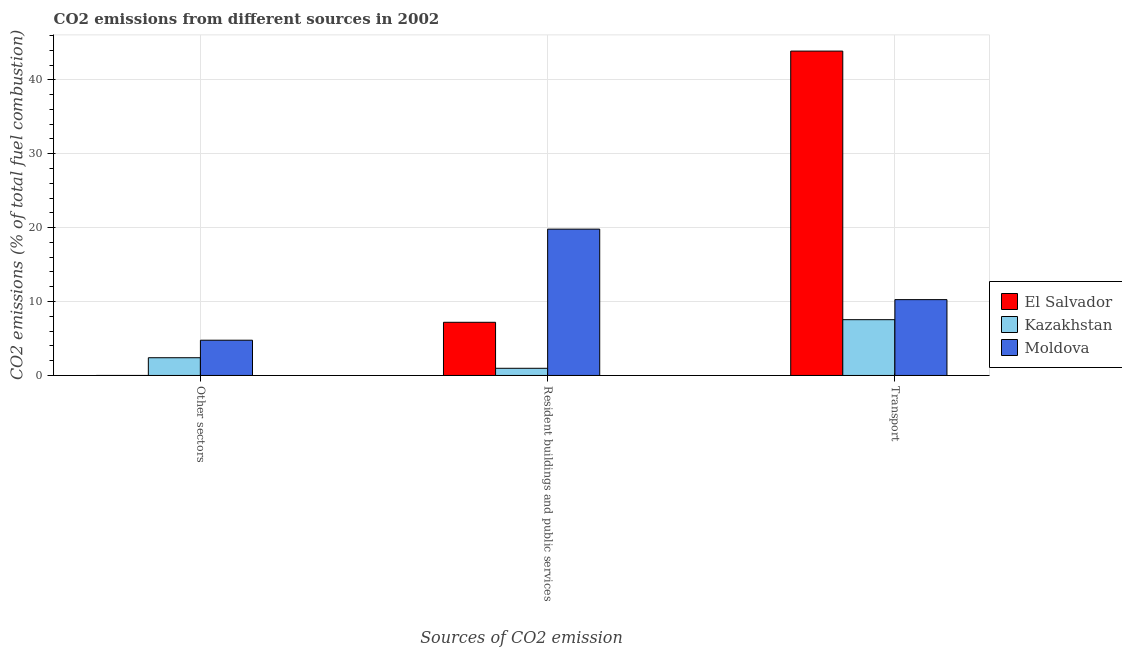How many groups of bars are there?
Your answer should be very brief. 3. Are the number of bars on each tick of the X-axis equal?
Your answer should be very brief. Yes. How many bars are there on the 3rd tick from the left?
Your answer should be very brief. 3. What is the label of the 1st group of bars from the left?
Offer a terse response. Other sectors. What is the percentage of co2 emissions from transport in Moldova?
Give a very brief answer. 10.26. Across all countries, what is the maximum percentage of co2 emissions from other sectors?
Give a very brief answer. 4.77. Across all countries, what is the minimum percentage of co2 emissions from transport?
Keep it short and to the point. 7.55. In which country was the percentage of co2 emissions from resident buildings and public services maximum?
Provide a short and direct response. Moldova. In which country was the percentage of co2 emissions from resident buildings and public services minimum?
Provide a short and direct response. Kazakhstan. What is the total percentage of co2 emissions from other sectors in the graph?
Your response must be concise. 7.17. What is the difference between the percentage of co2 emissions from transport in Kazakhstan and that in El Salvador?
Make the answer very short. -36.34. What is the difference between the percentage of co2 emissions from transport in Kazakhstan and the percentage of co2 emissions from resident buildings and public services in Moldova?
Give a very brief answer. -12.25. What is the average percentage of co2 emissions from transport per country?
Offer a terse response. 20.56. What is the difference between the percentage of co2 emissions from transport and percentage of co2 emissions from other sectors in Kazakhstan?
Make the answer very short. 5.15. In how many countries, is the percentage of co2 emissions from resident buildings and public services greater than 34 %?
Keep it short and to the point. 0. What is the ratio of the percentage of co2 emissions from transport in El Salvador to that in Moldova?
Ensure brevity in your answer.  4.28. Is the percentage of co2 emissions from other sectors in Kazakhstan less than that in Moldova?
Offer a terse response. Yes. What is the difference between the highest and the second highest percentage of co2 emissions from other sectors?
Your answer should be compact. 2.37. What is the difference between the highest and the lowest percentage of co2 emissions from other sectors?
Offer a terse response. 4.77. What does the 3rd bar from the left in Resident buildings and public services represents?
Your answer should be very brief. Moldova. What does the 2nd bar from the right in Resident buildings and public services represents?
Make the answer very short. Kazakhstan. Is it the case that in every country, the sum of the percentage of co2 emissions from other sectors and percentage of co2 emissions from resident buildings and public services is greater than the percentage of co2 emissions from transport?
Provide a short and direct response. No. How many bars are there?
Your answer should be very brief. 9. Does the graph contain any zero values?
Offer a terse response. No. How many legend labels are there?
Provide a succinct answer. 3. How are the legend labels stacked?
Provide a succinct answer. Vertical. What is the title of the graph?
Ensure brevity in your answer.  CO2 emissions from different sources in 2002. What is the label or title of the X-axis?
Your answer should be very brief. Sources of CO2 emission. What is the label or title of the Y-axis?
Offer a very short reply. CO2 emissions (% of total fuel combustion). What is the CO2 emissions (% of total fuel combustion) of El Salvador in Other sectors?
Make the answer very short. 1.56000312587842e-16. What is the CO2 emissions (% of total fuel combustion) of Kazakhstan in Other sectors?
Give a very brief answer. 2.4. What is the CO2 emissions (% of total fuel combustion) in Moldova in Other sectors?
Give a very brief answer. 4.77. What is the CO2 emissions (% of total fuel combustion) of El Salvador in Resident buildings and public services?
Provide a short and direct response. 7.19. What is the CO2 emissions (% of total fuel combustion) in Kazakhstan in Resident buildings and public services?
Your answer should be compact. 0.97. What is the CO2 emissions (% of total fuel combustion) in Moldova in Resident buildings and public services?
Provide a short and direct response. 19.8. What is the CO2 emissions (% of total fuel combustion) in El Salvador in Transport?
Give a very brief answer. 43.88. What is the CO2 emissions (% of total fuel combustion) in Kazakhstan in Transport?
Ensure brevity in your answer.  7.55. What is the CO2 emissions (% of total fuel combustion) of Moldova in Transport?
Offer a terse response. 10.26. Across all Sources of CO2 emission, what is the maximum CO2 emissions (% of total fuel combustion) in El Salvador?
Offer a terse response. 43.88. Across all Sources of CO2 emission, what is the maximum CO2 emissions (% of total fuel combustion) in Kazakhstan?
Offer a very short reply. 7.55. Across all Sources of CO2 emission, what is the maximum CO2 emissions (% of total fuel combustion) of Moldova?
Keep it short and to the point. 19.8. Across all Sources of CO2 emission, what is the minimum CO2 emissions (% of total fuel combustion) in El Salvador?
Provide a short and direct response. 1.56000312587842e-16. Across all Sources of CO2 emission, what is the minimum CO2 emissions (% of total fuel combustion) of Kazakhstan?
Your response must be concise. 0.97. Across all Sources of CO2 emission, what is the minimum CO2 emissions (% of total fuel combustion) in Moldova?
Keep it short and to the point. 4.77. What is the total CO2 emissions (% of total fuel combustion) of El Salvador in the graph?
Offer a very short reply. 51.08. What is the total CO2 emissions (% of total fuel combustion) in Kazakhstan in the graph?
Give a very brief answer. 10.92. What is the total CO2 emissions (% of total fuel combustion) of Moldova in the graph?
Make the answer very short. 34.83. What is the difference between the CO2 emissions (% of total fuel combustion) in El Salvador in Other sectors and that in Resident buildings and public services?
Provide a succinct answer. -7.19. What is the difference between the CO2 emissions (% of total fuel combustion) of Kazakhstan in Other sectors and that in Resident buildings and public services?
Make the answer very short. 1.43. What is the difference between the CO2 emissions (% of total fuel combustion) of Moldova in Other sectors and that in Resident buildings and public services?
Offer a very short reply. -15.03. What is the difference between the CO2 emissions (% of total fuel combustion) of El Salvador in Other sectors and that in Transport?
Keep it short and to the point. -43.88. What is the difference between the CO2 emissions (% of total fuel combustion) of Kazakhstan in Other sectors and that in Transport?
Give a very brief answer. -5.15. What is the difference between the CO2 emissions (% of total fuel combustion) of Moldova in Other sectors and that in Transport?
Your answer should be compact. -5.49. What is the difference between the CO2 emissions (% of total fuel combustion) in El Salvador in Resident buildings and public services and that in Transport?
Give a very brief answer. -36.69. What is the difference between the CO2 emissions (% of total fuel combustion) in Kazakhstan in Resident buildings and public services and that in Transport?
Ensure brevity in your answer.  -6.58. What is the difference between the CO2 emissions (% of total fuel combustion) in Moldova in Resident buildings and public services and that in Transport?
Your answer should be very brief. 9.54. What is the difference between the CO2 emissions (% of total fuel combustion) in El Salvador in Other sectors and the CO2 emissions (% of total fuel combustion) in Kazakhstan in Resident buildings and public services?
Your answer should be very brief. -0.97. What is the difference between the CO2 emissions (% of total fuel combustion) of El Salvador in Other sectors and the CO2 emissions (% of total fuel combustion) of Moldova in Resident buildings and public services?
Provide a succinct answer. -19.8. What is the difference between the CO2 emissions (% of total fuel combustion) in Kazakhstan in Other sectors and the CO2 emissions (% of total fuel combustion) in Moldova in Resident buildings and public services?
Ensure brevity in your answer.  -17.4. What is the difference between the CO2 emissions (% of total fuel combustion) of El Salvador in Other sectors and the CO2 emissions (% of total fuel combustion) of Kazakhstan in Transport?
Offer a terse response. -7.55. What is the difference between the CO2 emissions (% of total fuel combustion) of El Salvador in Other sectors and the CO2 emissions (% of total fuel combustion) of Moldova in Transport?
Your response must be concise. -10.26. What is the difference between the CO2 emissions (% of total fuel combustion) in Kazakhstan in Other sectors and the CO2 emissions (% of total fuel combustion) in Moldova in Transport?
Your answer should be compact. -7.86. What is the difference between the CO2 emissions (% of total fuel combustion) of El Salvador in Resident buildings and public services and the CO2 emissions (% of total fuel combustion) of Kazakhstan in Transport?
Ensure brevity in your answer.  -0.35. What is the difference between the CO2 emissions (% of total fuel combustion) in El Salvador in Resident buildings and public services and the CO2 emissions (% of total fuel combustion) in Moldova in Transport?
Your answer should be very brief. -3.07. What is the difference between the CO2 emissions (% of total fuel combustion) of Kazakhstan in Resident buildings and public services and the CO2 emissions (% of total fuel combustion) of Moldova in Transport?
Make the answer very short. -9.29. What is the average CO2 emissions (% of total fuel combustion) in El Salvador per Sources of CO2 emission?
Give a very brief answer. 17.03. What is the average CO2 emissions (% of total fuel combustion) in Kazakhstan per Sources of CO2 emission?
Offer a very short reply. 3.64. What is the average CO2 emissions (% of total fuel combustion) of Moldova per Sources of CO2 emission?
Provide a short and direct response. 11.61. What is the difference between the CO2 emissions (% of total fuel combustion) of El Salvador and CO2 emissions (% of total fuel combustion) of Kazakhstan in Other sectors?
Make the answer very short. -2.4. What is the difference between the CO2 emissions (% of total fuel combustion) in El Salvador and CO2 emissions (% of total fuel combustion) in Moldova in Other sectors?
Offer a terse response. -4.77. What is the difference between the CO2 emissions (% of total fuel combustion) of Kazakhstan and CO2 emissions (% of total fuel combustion) of Moldova in Other sectors?
Make the answer very short. -2.37. What is the difference between the CO2 emissions (% of total fuel combustion) in El Salvador and CO2 emissions (% of total fuel combustion) in Kazakhstan in Resident buildings and public services?
Your response must be concise. 6.22. What is the difference between the CO2 emissions (% of total fuel combustion) in El Salvador and CO2 emissions (% of total fuel combustion) in Moldova in Resident buildings and public services?
Your answer should be compact. -12.6. What is the difference between the CO2 emissions (% of total fuel combustion) in Kazakhstan and CO2 emissions (% of total fuel combustion) in Moldova in Resident buildings and public services?
Your answer should be very brief. -18.83. What is the difference between the CO2 emissions (% of total fuel combustion) in El Salvador and CO2 emissions (% of total fuel combustion) in Kazakhstan in Transport?
Keep it short and to the point. 36.34. What is the difference between the CO2 emissions (% of total fuel combustion) in El Salvador and CO2 emissions (% of total fuel combustion) in Moldova in Transport?
Your answer should be compact. 33.62. What is the difference between the CO2 emissions (% of total fuel combustion) of Kazakhstan and CO2 emissions (% of total fuel combustion) of Moldova in Transport?
Offer a very short reply. -2.71. What is the ratio of the CO2 emissions (% of total fuel combustion) in Kazakhstan in Other sectors to that in Resident buildings and public services?
Offer a terse response. 2.47. What is the ratio of the CO2 emissions (% of total fuel combustion) in Moldova in Other sectors to that in Resident buildings and public services?
Offer a terse response. 0.24. What is the ratio of the CO2 emissions (% of total fuel combustion) in El Salvador in Other sectors to that in Transport?
Ensure brevity in your answer.  0. What is the ratio of the CO2 emissions (% of total fuel combustion) in Kazakhstan in Other sectors to that in Transport?
Make the answer very short. 0.32. What is the ratio of the CO2 emissions (% of total fuel combustion) in Moldova in Other sectors to that in Transport?
Your answer should be compact. 0.46. What is the ratio of the CO2 emissions (% of total fuel combustion) of El Salvador in Resident buildings and public services to that in Transport?
Offer a terse response. 0.16. What is the ratio of the CO2 emissions (% of total fuel combustion) in Kazakhstan in Resident buildings and public services to that in Transport?
Your answer should be very brief. 0.13. What is the ratio of the CO2 emissions (% of total fuel combustion) of Moldova in Resident buildings and public services to that in Transport?
Provide a short and direct response. 1.93. What is the difference between the highest and the second highest CO2 emissions (% of total fuel combustion) of El Salvador?
Your answer should be compact. 36.69. What is the difference between the highest and the second highest CO2 emissions (% of total fuel combustion) of Kazakhstan?
Give a very brief answer. 5.15. What is the difference between the highest and the second highest CO2 emissions (% of total fuel combustion) of Moldova?
Your response must be concise. 9.54. What is the difference between the highest and the lowest CO2 emissions (% of total fuel combustion) in El Salvador?
Provide a succinct answer. 43.88. What is the difference between the highest and the lowest CO2 emissions (% of total fuel combustion) in Kazakhstan?
Give a very brief answer. 6.58. What is the difference between the highest and the lowest CO2 emissions (% of total fuel combustion) of Moldova?
Your answer should be compact. 15.03. 